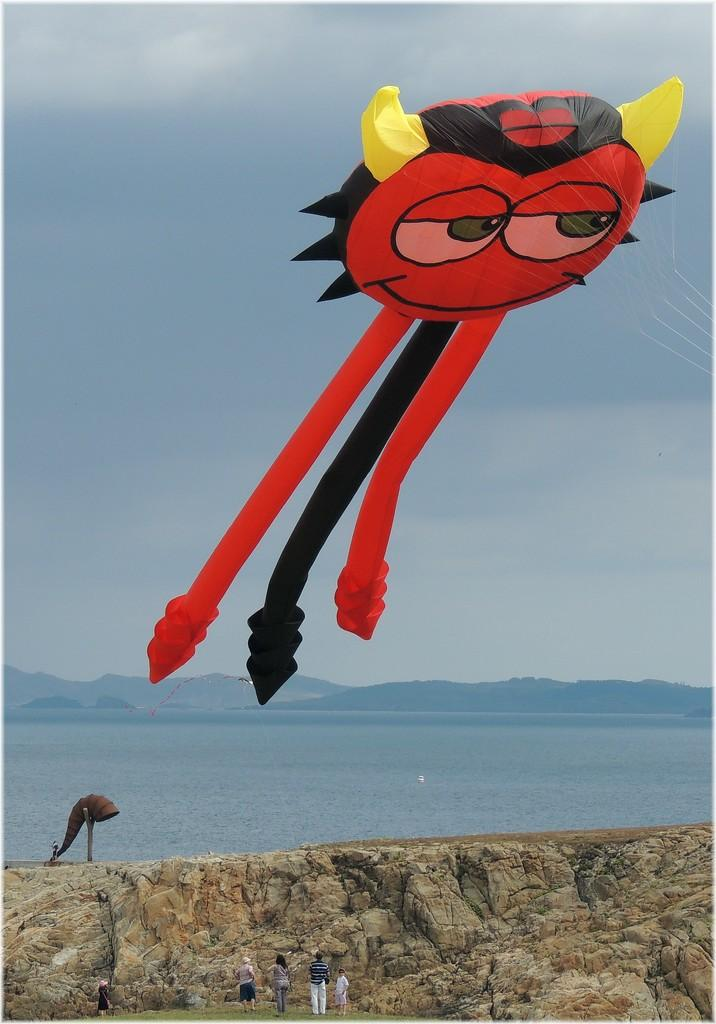What is the main subject of the image? The main subject of the image is an air balloon. What color is the air balloon? The air balloon is red in color. What can be seen near the air balloon? There are people standing near the air balloon. What else is visible in the image besides the air balloon and people? There is water and the sky visible in the image. What type of brass vessel can be seen floating on the water in the image? There is no brass vessel present in the image; it features an air balloon and people near it. Can you describe the bite marks on the air balloon in the image? There are no bite marks visible on the air balloon in the image. 